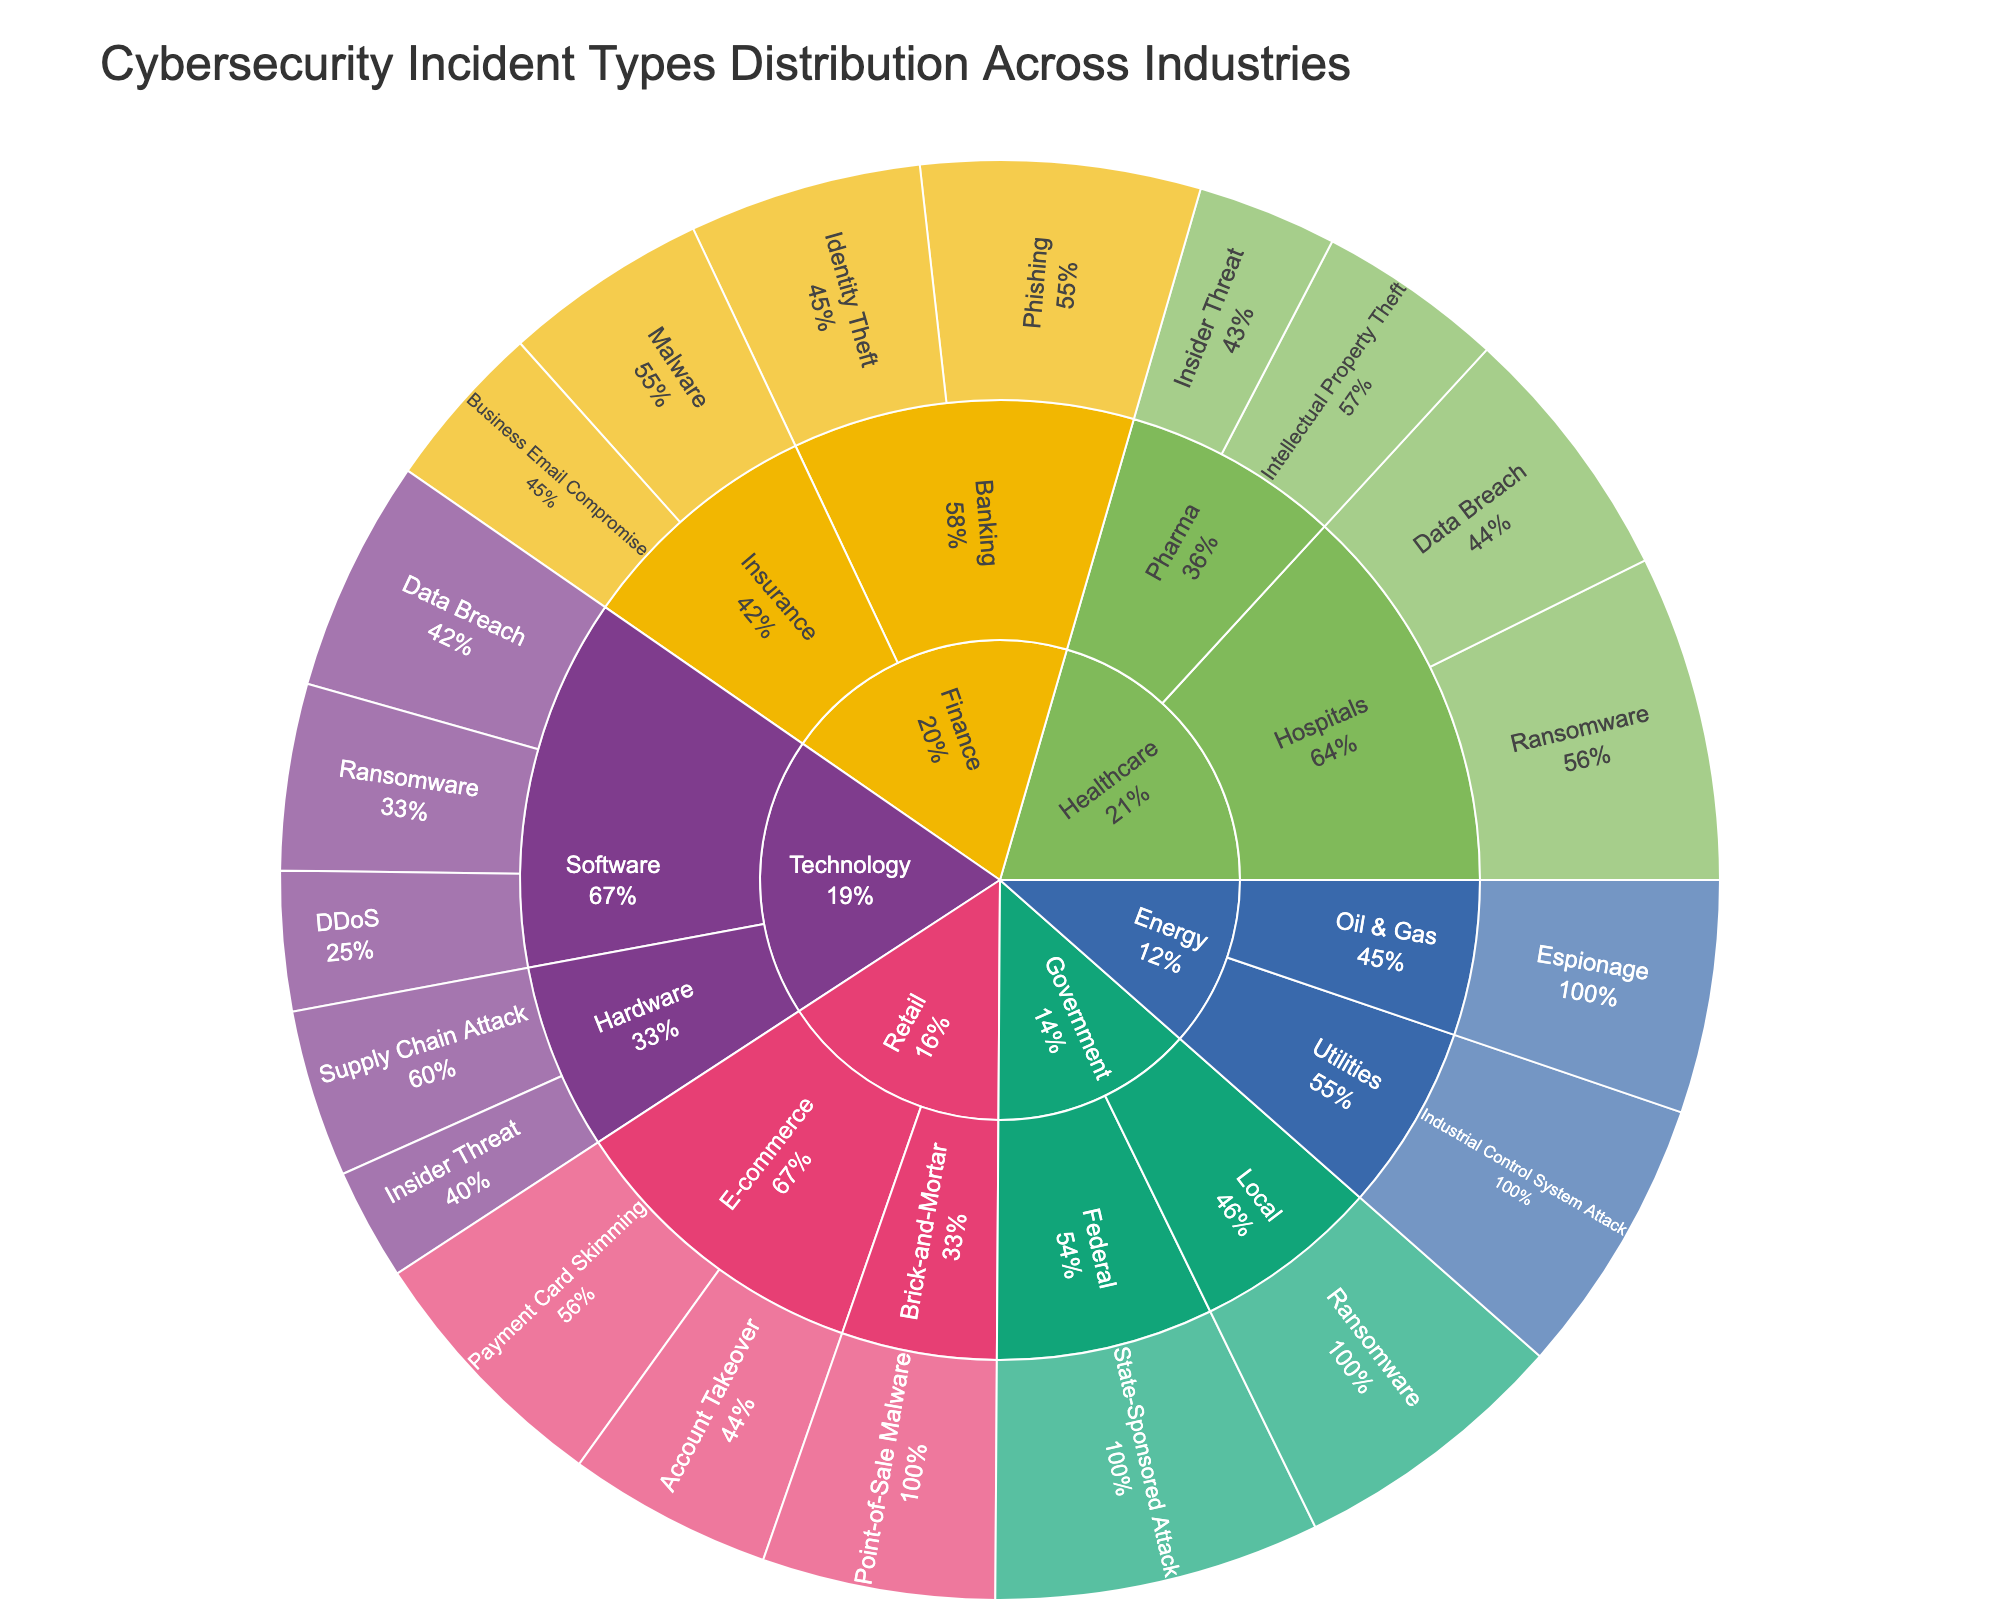What's the title of the figure? The title is displayed at the top of the Sunburst Plot, usually in a larger font than the rest of the text.
Answer: Cybersecurity Incident Types Distribution Across Industries Which industry has the highest percentage of ransomware incidents in total? To find this, identify the segments labeled "Ransomware" and observe the percentages associated with different industries.
Answer: Healthcare What is the combined percentage of Data Breach incidents in the Technology sector? Locate the "Data Breach" incidents within the "Technology" sector and sum their percentages.
Answer: 25% Which sector in the Finance industry experiences the highest percentage of incidents related to Phishing? Find the "Finance" industry, then look for "Banking" and "Insurance" sectors and compare their Phishing incident percentages.
Answer: Banking How does the percentage of Industrial Control System Attacks in the Energy industry compare to Espionage in the same industry? Within the "Energy" industry, compare the percentage values for "Industrial Control System Attack" and "Espionage."
Answer: Industrial Control System Attacks are higher Which incident type has the highest percentage within the Government industry? Look at the two segments under "Government" and identify the incident type with the highest percentage.
Answer: State-Sponsored Attack In the Healthcare industry, which sector has a higher percentage of Ransomware incidents, Hospitals or Pharma? Locate the "Healthcare" industry, then check the "Ransomware" percentages for both "Hospitals" and "Pharma" sectors.
Answer: Hospitals What is the total percentage of all incidents within the Retail industry? Sum the percentages of all incident types in both "E-commerce" and "Brick-and-Mortar" sectors under the "Retail" industry.
Answer: 75% Which industry shows a higher incidence of Supply Chain Attacks, Technology, or Finance? Find the "Supply Chain Attack" segments in both "Technology" and "Finance" industries and compare their percentages.
Answer: Technology What percentage of incidents in the Local Government sector are Ransomware? Identify the "Local" segment under "Government" and observe the percentage for "Ransomware" incidents.
Answer: 30% 